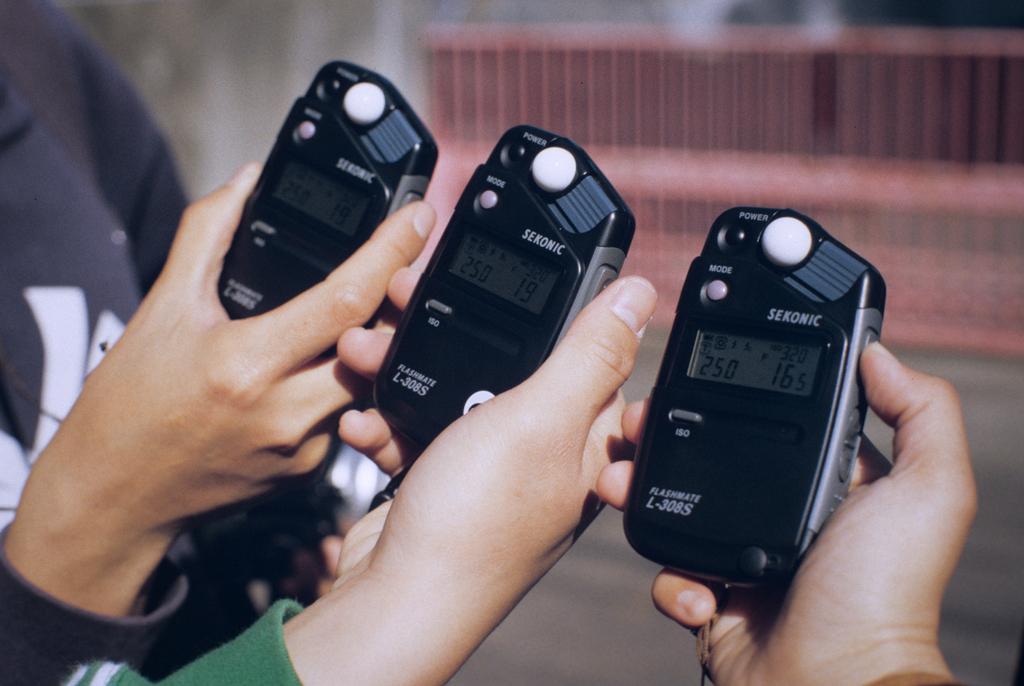In one or two sentences, can you explain what this image depicts? In this picture we can see hands of people holding devices. In the background of the image it is blurry and we can see fence. 